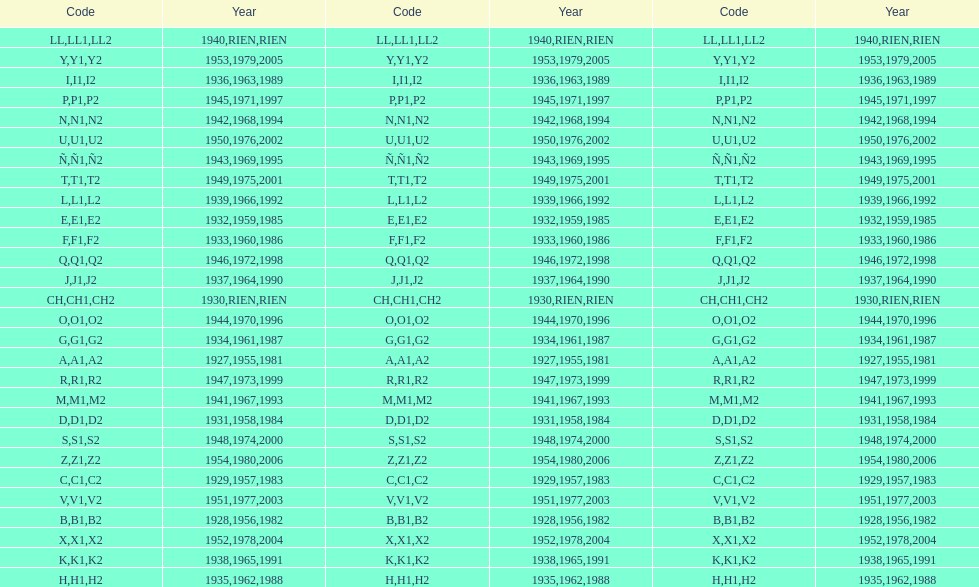How many different codes were used from 1953 to 1958? 6. 